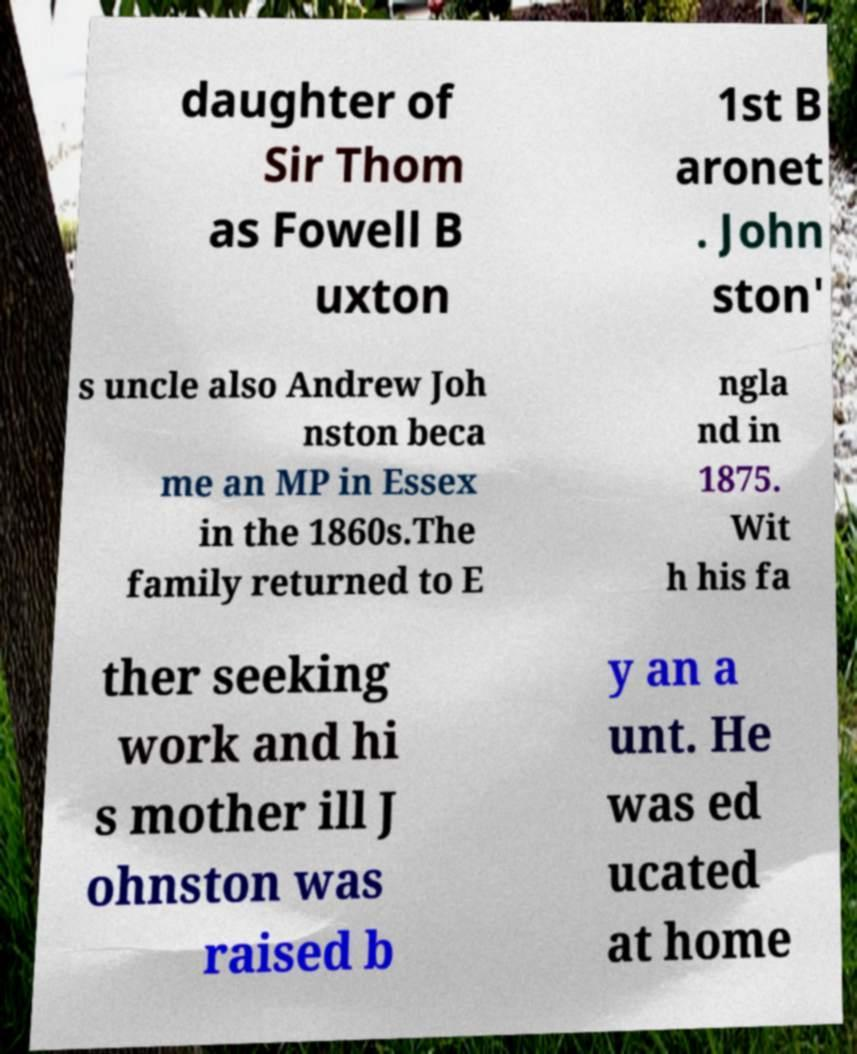Can you accurately transcribe the text from the provided image for me? daughter of Sir Thom as Fowell B uxton 1st B aronet . John ston' s uncle also Andrew Joh nston beca me an MP in Essex in the 1860s.The family returned to E ngla nd in 1875. Wit h his fa ther seeking work and hi s mother ill J ohnston was raised b y an a unt. He was ed ucated at home 